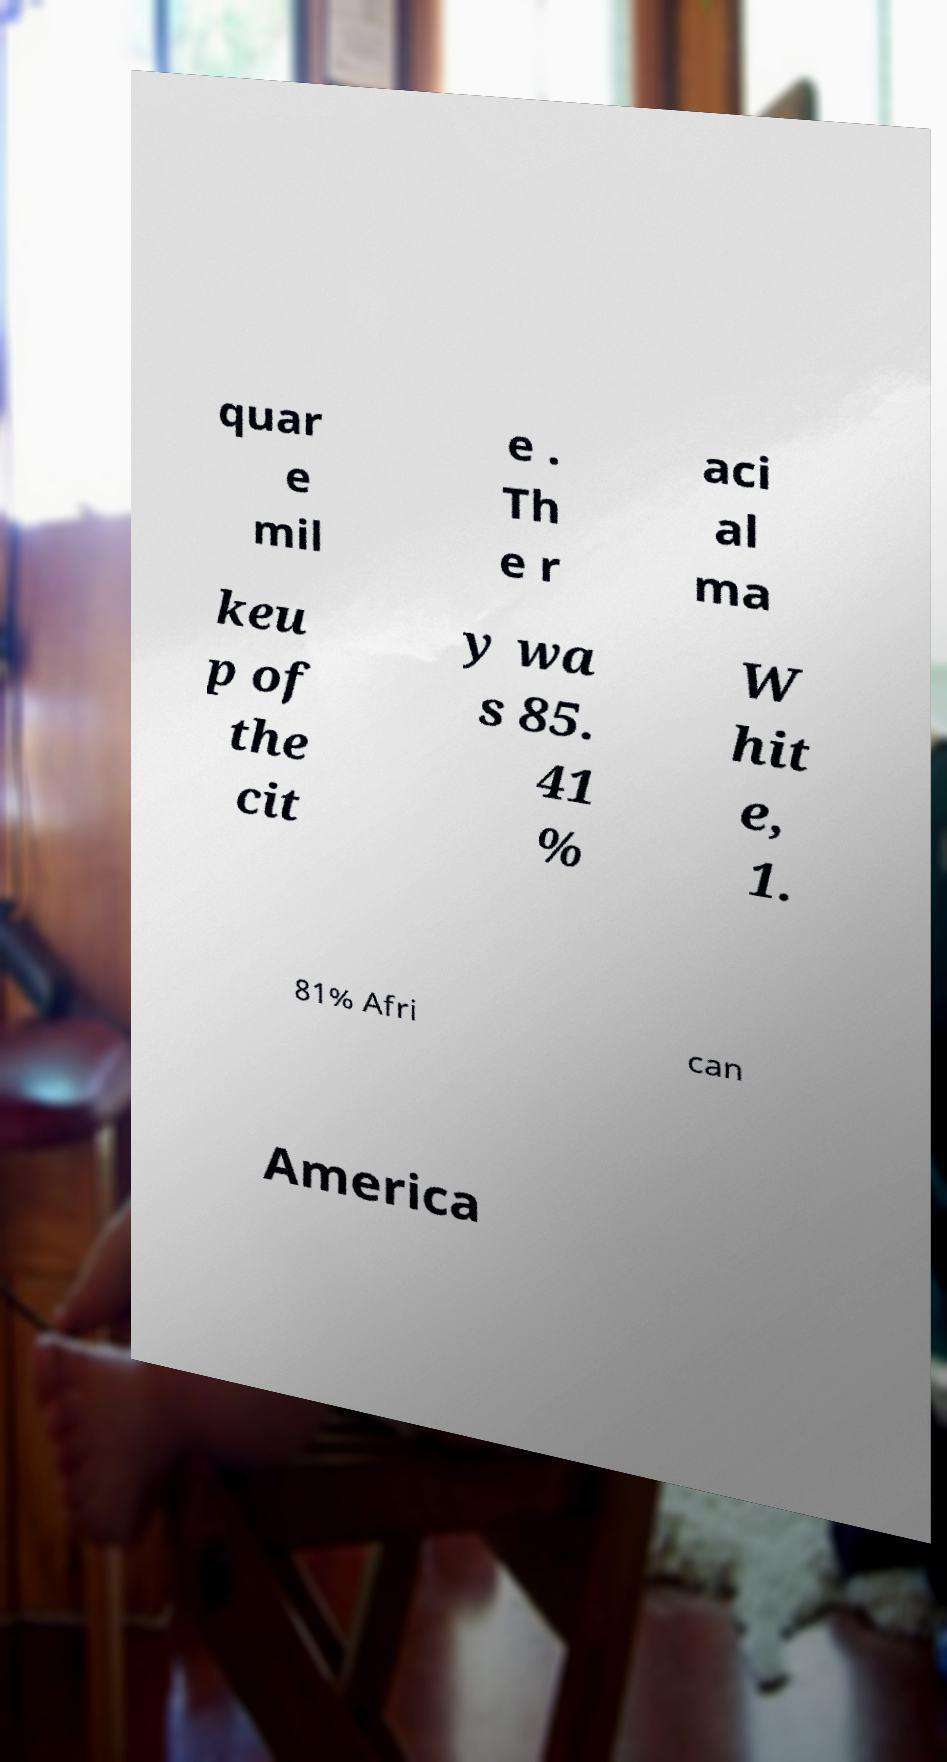There's text embedded in this image that I need extracted. Can you transcribe it verbatim? quar e mil e . Th e r aci al ma keu p of the cit y wa s 85. 41 % W hit e, 1. 81% Afri can America 